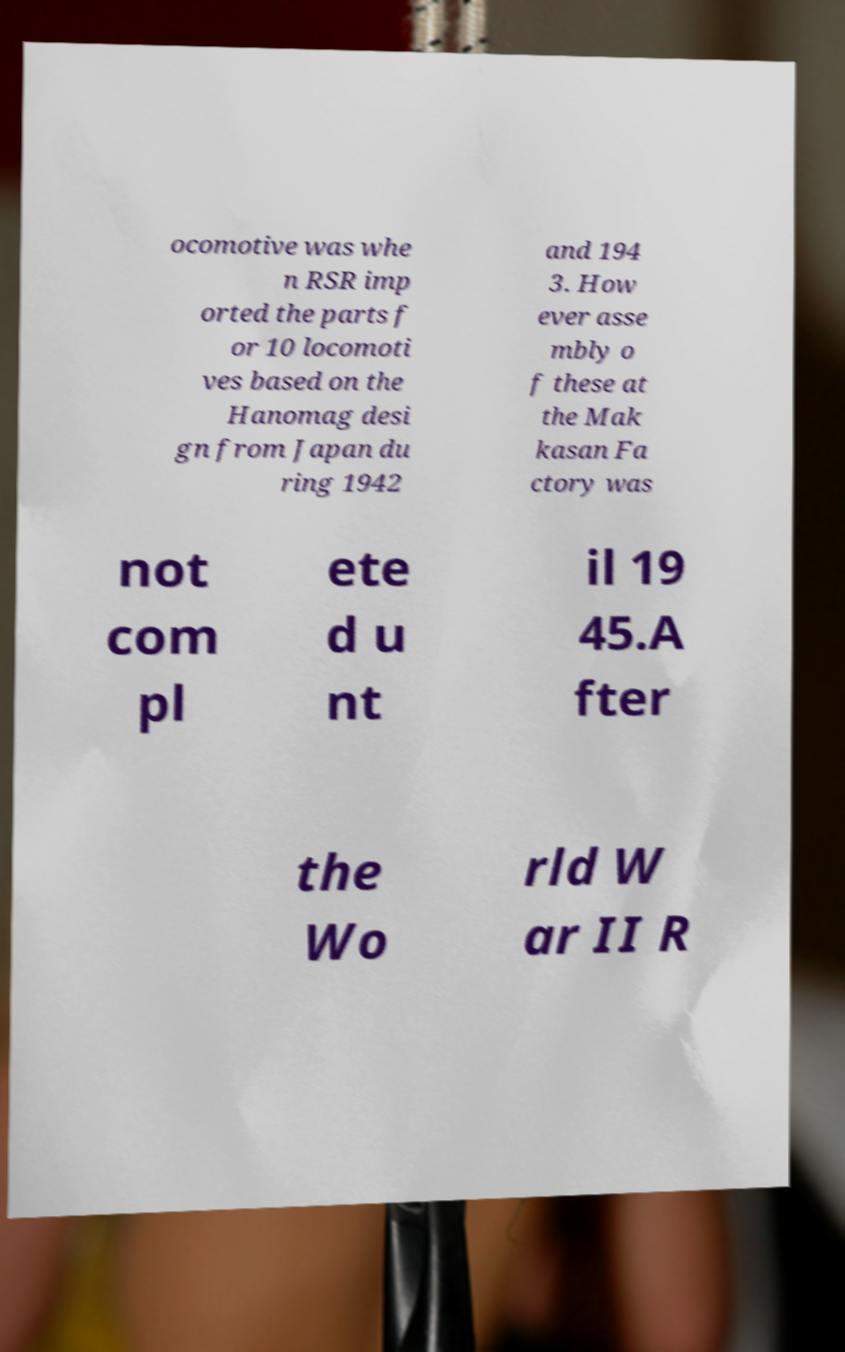I need the written content from this picture converted into text. Can you do that? ocomotive was whe n RSR imp orted the parts f or 10 locomoti ves based on the Hanomag desi gn from Japan du ring 1942 and 194 3. How ever asse mbly o f these at the Mak kasan Fa ctory was not com pl ete d u nt il 19 45.A fter the Wo rld W ar II R 